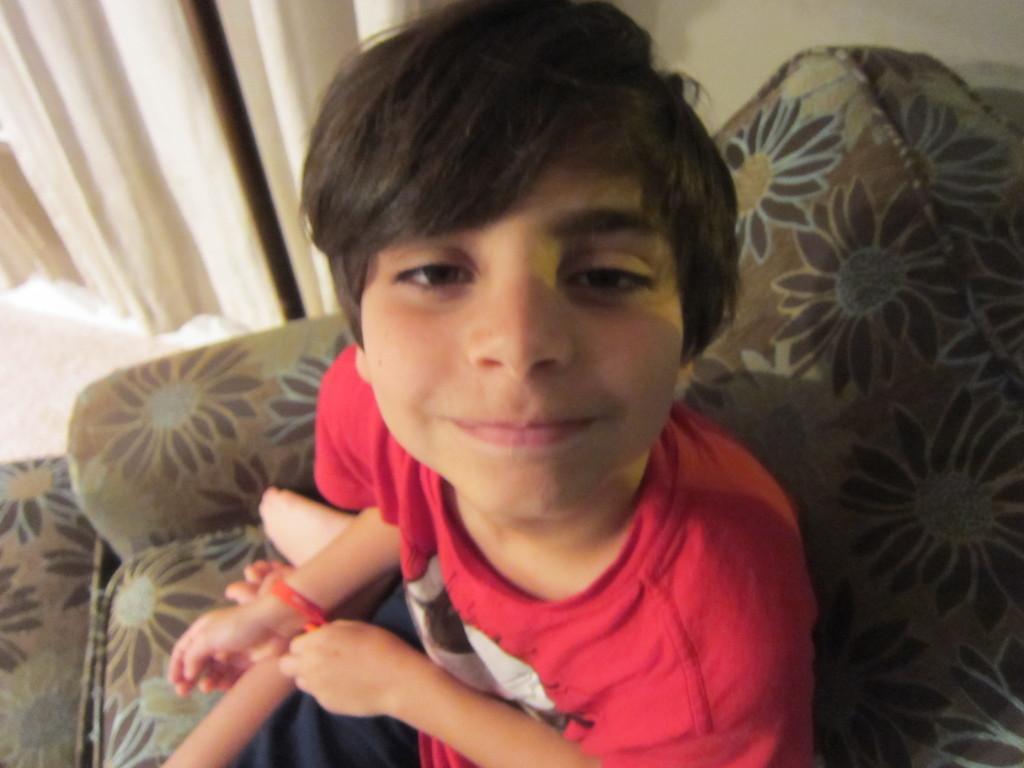In one or two sentences, can you explain what this image depicts? In the foreground of this image, there is a boy sitting on sofa. In the background, there is a wall and a curtain. 